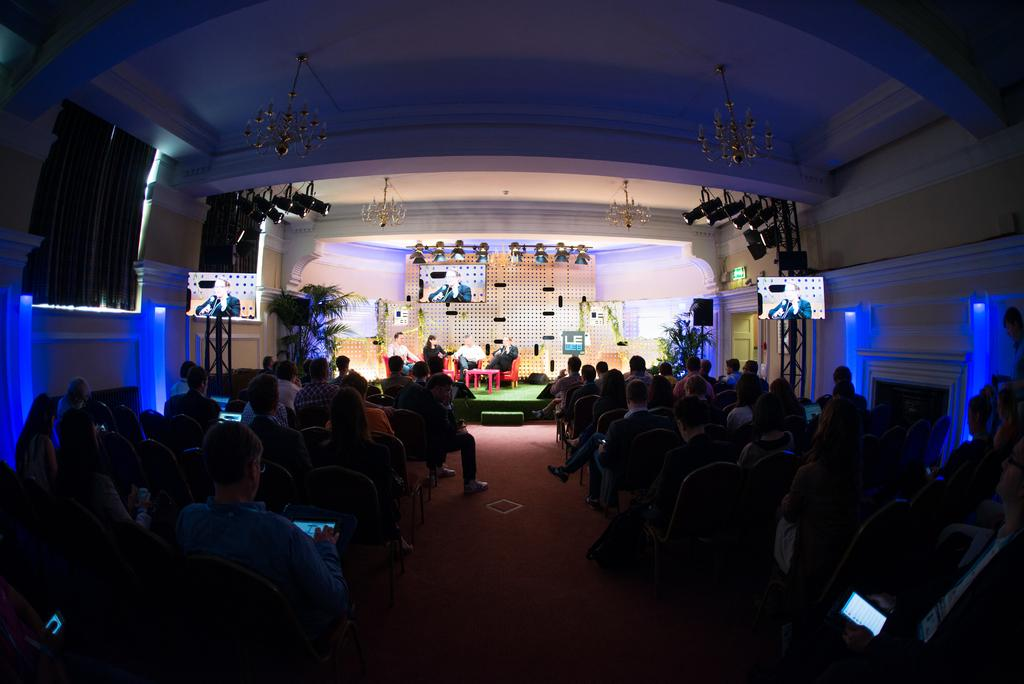What are the people in the image doing? People are sitting on chairs in the image. What are two of the people holding? Two people are holding devices in the image. How many screens can be seen in the image? There are three screens visible in the image. What type of lighting is present in the scene? Focusing lights are present in the image. What type of vegetation is in the image? There is a plant in the image. What type of window treatment is present in the scene? Curtains are in the scene. What type of mailbox is visible in the image? There is no mailbox present in the image. How many people are eating a meal in the image? There is no meal being eaten in the image, so it cannot be determined how many people might be eating. 